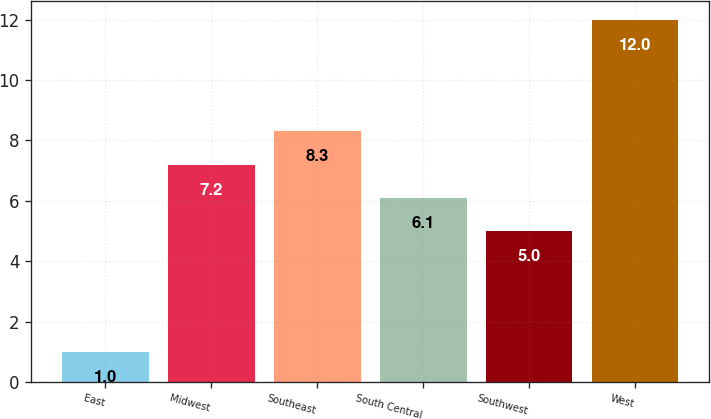Convert chart. <chart><loc_0><loc_0><loc_500><loc_500><bar_chart><fcel>East<fcel>Midwest<fcel>Southeast<fcel>South Central<fcel>Southwest<fcel>West<nl><fcel>1<fcel>7.2<fcel>8.3<fcel>6.1<fcel>5<fcel>12<nl></chart> 